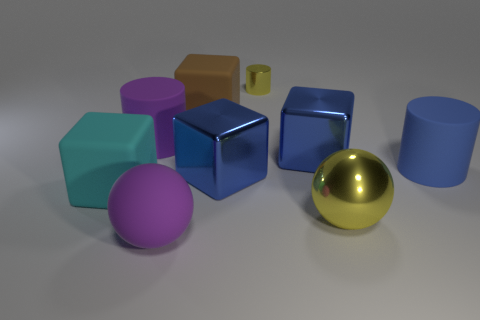There is another object that is the same color as the tiny metallic thing; what shape is it?
Your answer should be very brief. Sphere. How many other things are there of the same size as the rubber sphere?
Give a very brief answer. 7. Is the color of the big cylinder that is behind the large blue matte cylinder the same as the matte block that is to the left of the big brown object?
Make the answer very short. No. What size is the rubber cylinder that is in front of the big rubber cylinder that is to the left of the big cylinder on the right side of the tiny yellow metal thing?
Give a very brief answer. Large. There is a large object that is both in front of the cyan cube and on the left side of the big yellow shiny sphere; what is its shape?
Your answer should be very brief. Sphere. Is the number of blocks that are in front of the large brown cube the same as the number of large brown rubber blocks in front of the big cyan block?
Your response must be concise. No. Is there a tiny purple object made of the same material as the large cyan thing?
Keep it short and to the point. No. Are the yellow object on the right side of the small metallic thing and the tiny yellow thing made of the same material?
Your answer should be compact. Yes. There is a cylinder that is both right of the purple sphere and in front of the large brown object; what size is it?
Offer a very short reply. Large. What is the color of the small metallic object?
Make the answer very short. Yellow. 